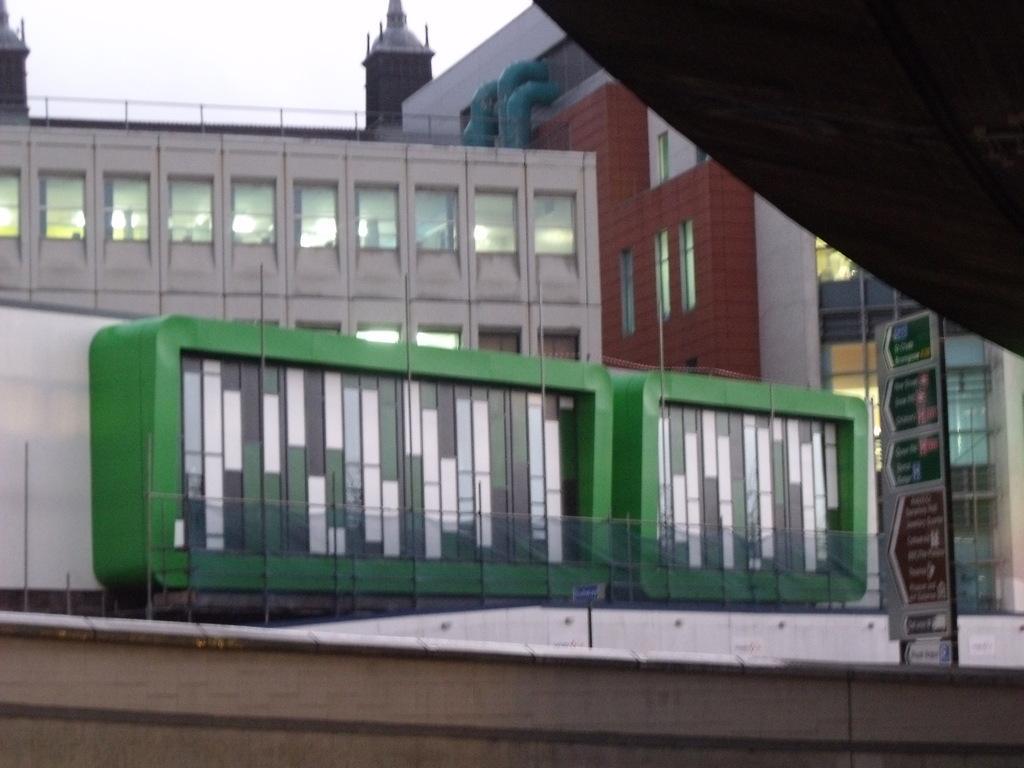Could you give a brief overview of what you see in this image? There are some buildings as we can see in the middle of this image and there is a board on the right side of this image, and there is a sky at the top of this image. 